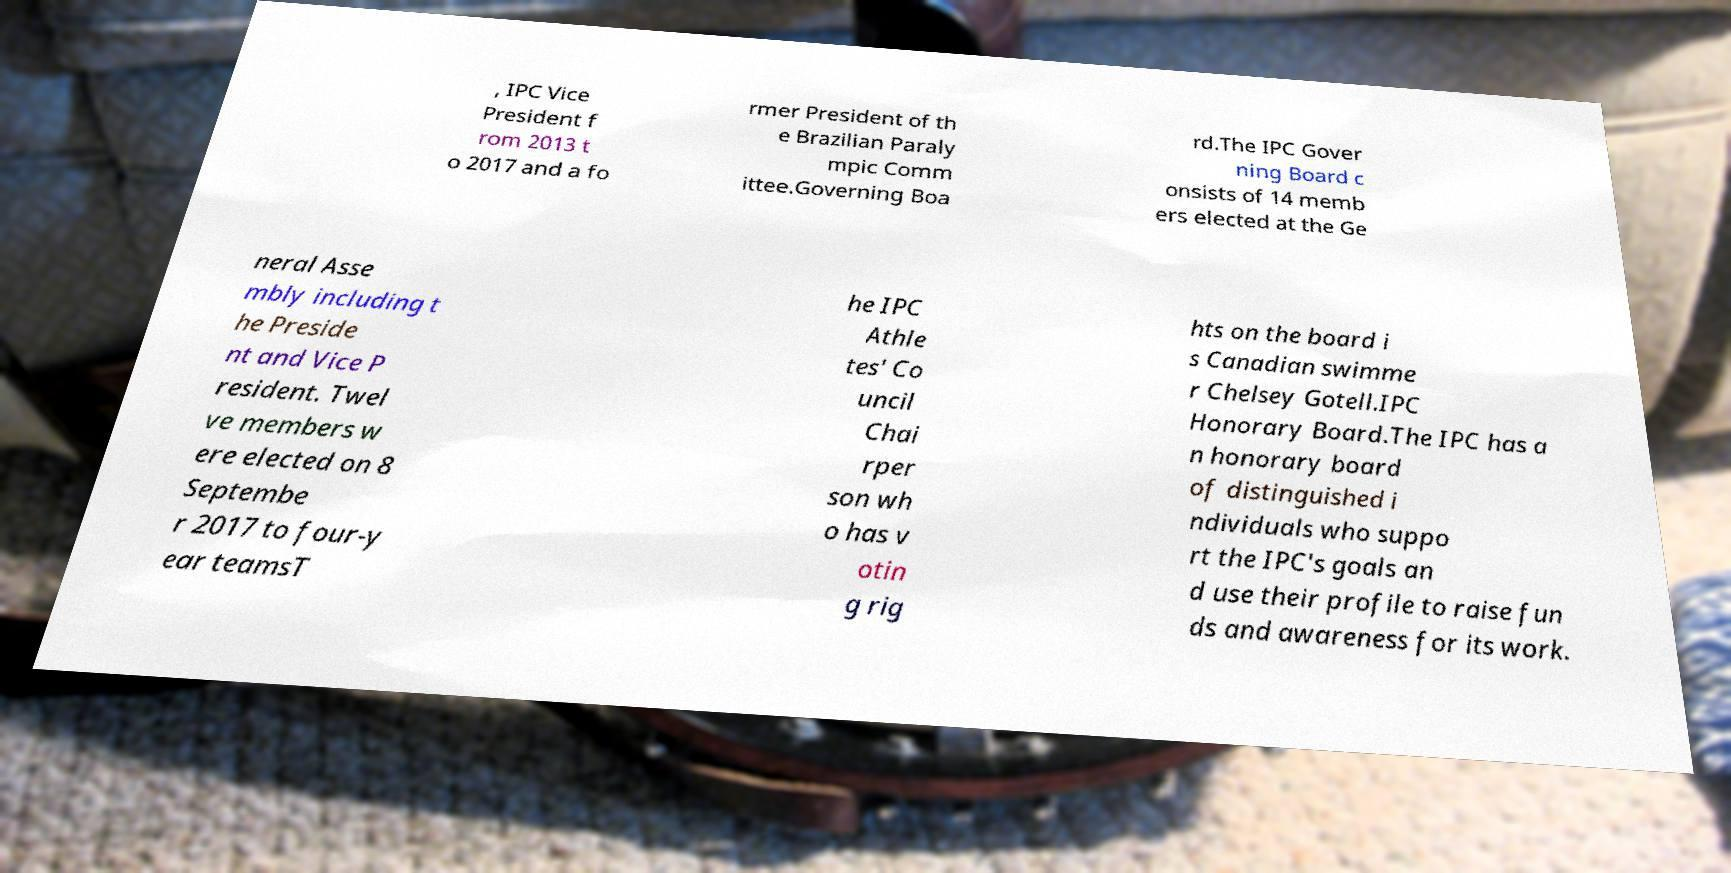Please identify and transcribe the text found in this image. , IPC Vice President f rom 2013 t o 2017 and a fo rmer President of th e Brazilian Paraly mpic Comm ittee.Governing Boa rd.The IPC Gover ning Board c onsists of 14 memb ers elected at the Ge neral Asse mbly including t he Preside nt and Vice P resident. Twel ve members w ere elected on 8 Septembe r 2017 to four-y ear teamsT he IPC Athle tes' Co uncil Chai rper son wh o has v otin g rig hts on the board i s Canadian swimme r Chelsey Gotell.IPC Honorary Board.The IPC has a n honorary board of distinguished i ndividuals who suppo rt the IPC's goals an d use their profile to raise fun ds and awareness for its work. 